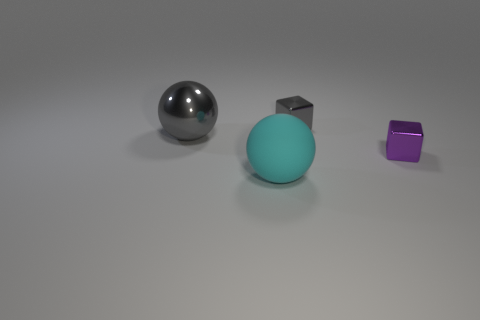Can you describe the objects and their colors in the image? Certainly! There's one metallic sphere with a reflective surface, a larger, matte teal sphere, and a small purple cube. The lighting creates soft shadows on the ground plane. 